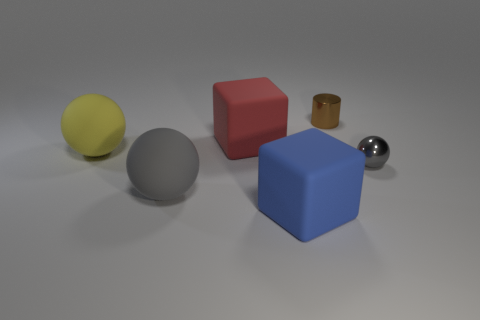Add 2 red spheres. How many objects exist? 8 Subtract all blocks. How many objects are left? 4 Subtract 0 green blocks. How many objects are left? 6 Subtract all large purple metal cubes. Subtract all large gray things. How many objects are left? 5 Add 1 red matte objects. How many red matte objects are left? 2 Add 4 matte cylinders. How many matte cylinders exist? 4 